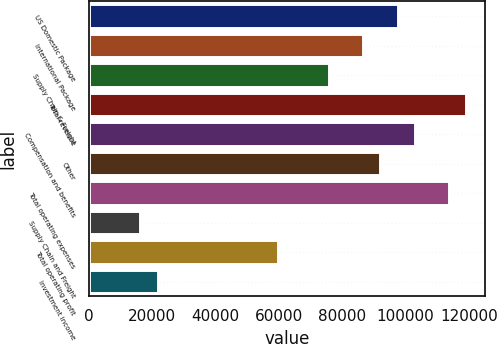<chart> <loc_0><loc_0><loc_500><loc_500><bar_chart><fcel>US Domestic Package<fcel>International Package<fcel>Supply Chain & Freight<fcel>Total revenue<fcel>Compensation and benefits<fcel>Other<fcel>Total operating expenses<fcel>Supply Chain and Freight<fcel>Total operating profit<fcel>Investment income<nl><fcel>97428<fcel>86602.8<fcel>75777.5<fcel>119078<fcel>102841<fcel>92015.4<fcel>113666<fcel>16238.7<fcel>59539.7<fcel>21651.3<nl></chart> 